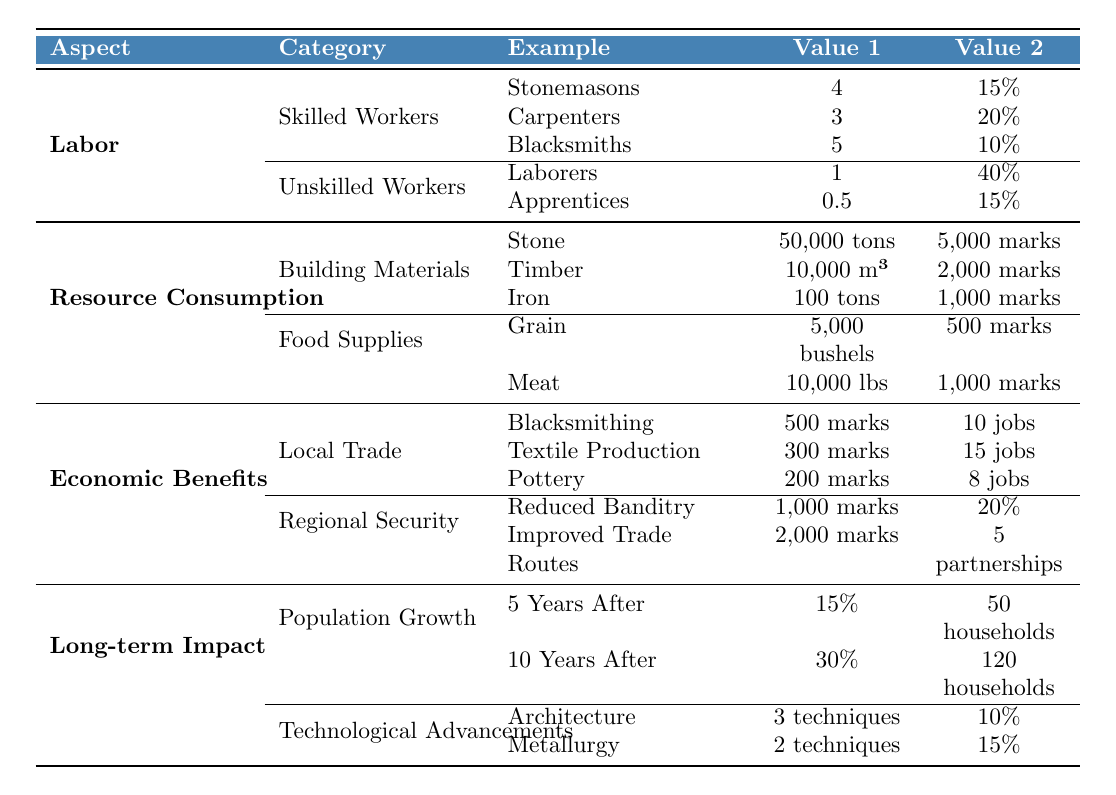What is the average daily wage of stonemasons? The wage for stonemasons is listed in the table as 4 silver pennies. Since there is only one value given for stonemasons, the average wage is also 4 silver pennies.
Answer: 4 How many jobs were created in the textile production sector? According to the table, the textile production sector created 15 jobs, as indicated in the economic benefits section.
Answer: 15 What is the total cost of building materials used in castle construction? The costs for building materials are: Stone = 5000 marks, Timber = 2000 marks, Iron = 1000 marks. Summing these gives 5000 + 2000 + 1000 = 8000 marks.
Answer: 8000 marks What percentage of the total workforce consists of laborers? The percentage of laborers is listed as 40%. Since this is a direct retrieval from the table, no calculations are needed.
Answer: 40% How many techniques were developed in metallurgy? The table states that 2 new techniques were developed in metallurgy, which is directly retrievable from the data.
Answer: 2 How much money did local trade in blacksmithing increase annually? The annual revenue increase from blacksmithing is noted as 500 silver marks in the table. This is a straightforward retrieval.
Answer: 500 silver marks What is the combined annual revenue increase from local trade sectors of blacksmithing, textile production, and pottery? The annual revenue increases are: Blacksmithing = 500 marks, Textile Production = 300 marks, Pottery = 200 marks. Adding these together gives 500 + 300 + 200 = 1000 marks.
Answer: 1000 marks Is the annual savings from reduced banditry greater than the annual revenue increase from blacksmithing? The annual savings from reduced banditry is 1000 marks, which is equal to the annual revenue increase from blacksmithing (500 marks) and exceeds it. Therefore, the statement is true.
Answer: Yes What is the population increase percentage 10 years after castle construction? The table states that the population increase 10 years after construction is 30%. This value is directly found in the long-term impact section.
Answer: 30% How many total new households were formed 5 years after construction compared to 10 years after? The number of new households after 5 years is 50, and after 10 years it is 120. The increase in new households from 5 to 10 years is calculated as 120 - 50 = 70.
Answer: 70 households If you were to combine the efficiency improvements from architecture and metallurgy, what would be the total percentage improvement? The efficiency improvements are 10% for architecture and 15% for metallurgy. Adding these together results in 10 + 15 = 25%.
Answer: 25% 